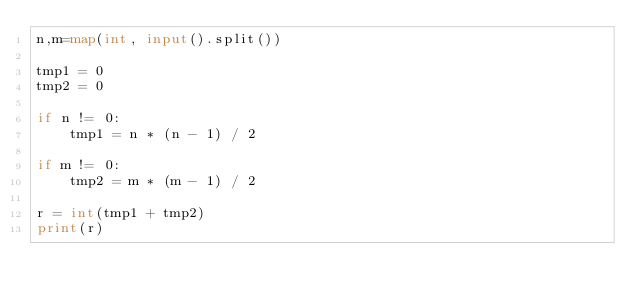Convert code to text. <code><loc_0><loc_0><loc_500><loc_500><_Python_>n,m=map(int, input().split()) 

tmp1 = 0
tmp2 = 0

if n != 0:
    tmp1 = n * (n - 1) / 2

if m != 0:
    tmp2 = m * (m - 1) / 2

r = int(tmp1 + tmp2)
print(r)</code> 